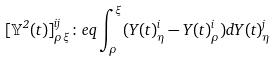<formula> <loc_0><loc_0><loc_500><loc_500>[ \mathbb { Y } ^ { 2 } ( t ) ] ^ { i j } _ { \rho \xi } \colon e q \int _ { \rho } ^ { \xi } ( Y ( t ) ^ { i } _ { \eta } - Y ( t ) ^ { i } _ { \rho } ) d Y ( t ) ^ { j } _ { \eta }</formula> 